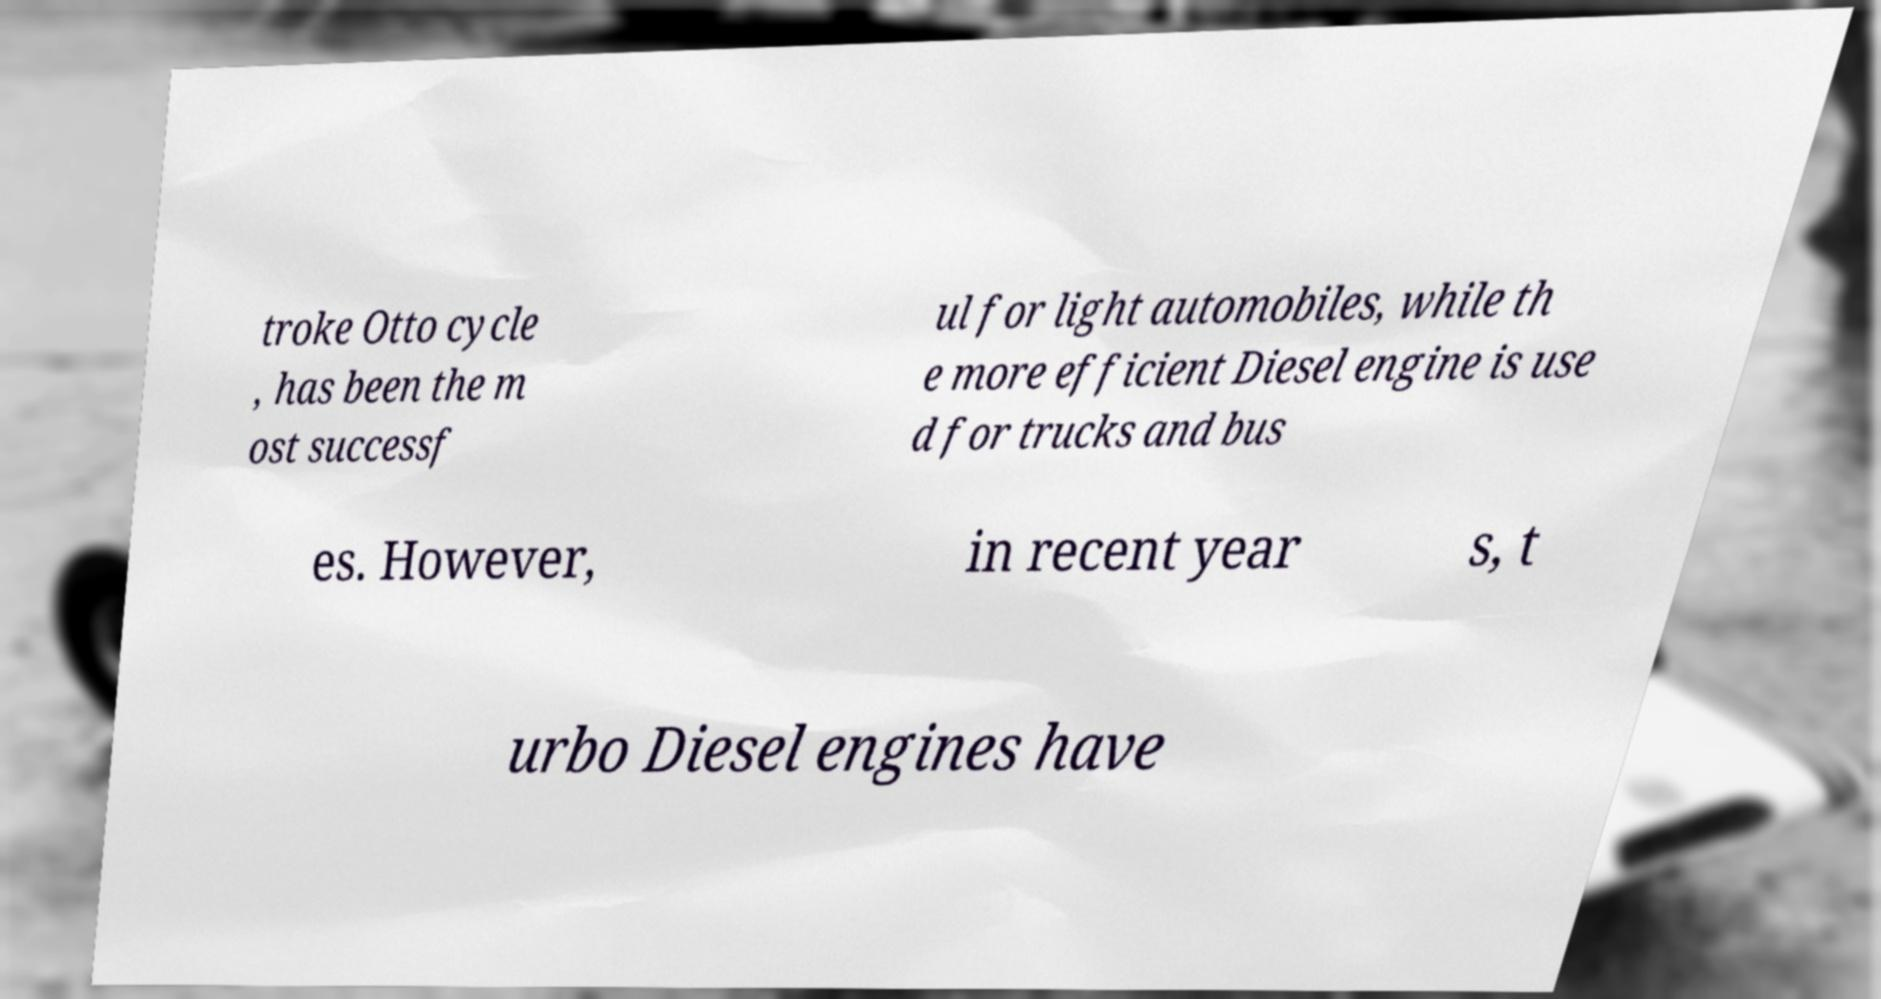For documentation purposes, I need the text within this image transcribed. Could you provide that? troke Otto cycle , has been the m ost successf ul for light automobiles, while th e more efficient Diesel engine is use d for trucks and bus es. However, in recent year s, t urbo Diesel engines have 